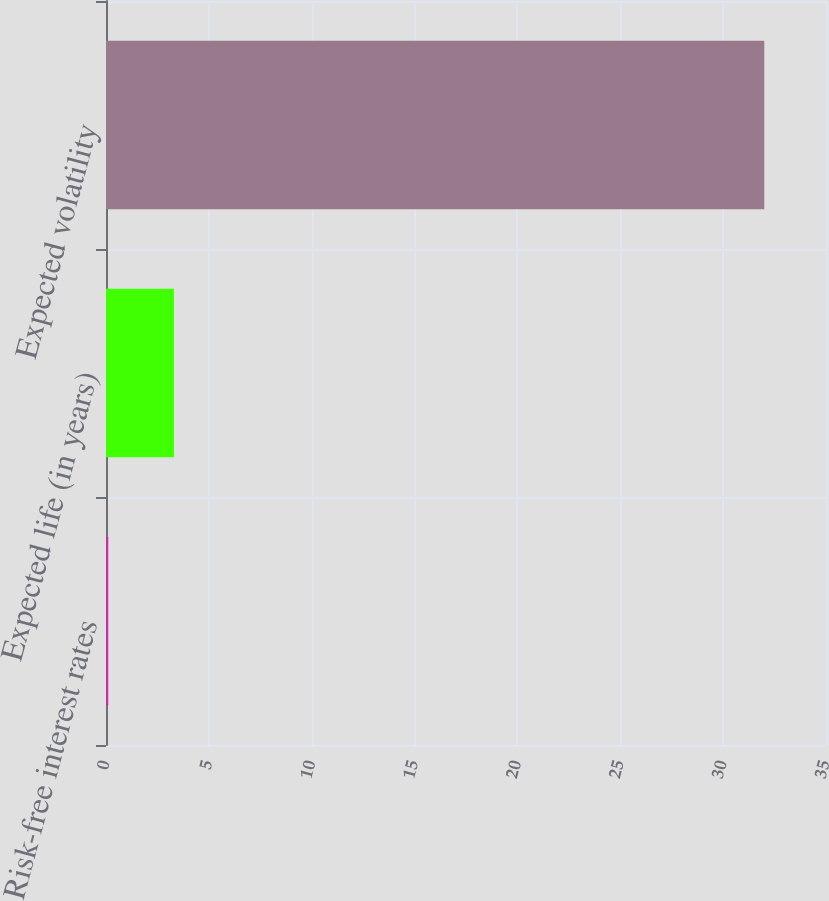Convert chart to OTSL. <chart><loc_0><loc_0><loc_500><loc_500><bar_chart><fcel>Risk-free interest rates<fcel>Expected life (in years)<fcel>Expected volatility<nl><fcel>0.11<fcel>3.3<fcel>32<nl></chart> 